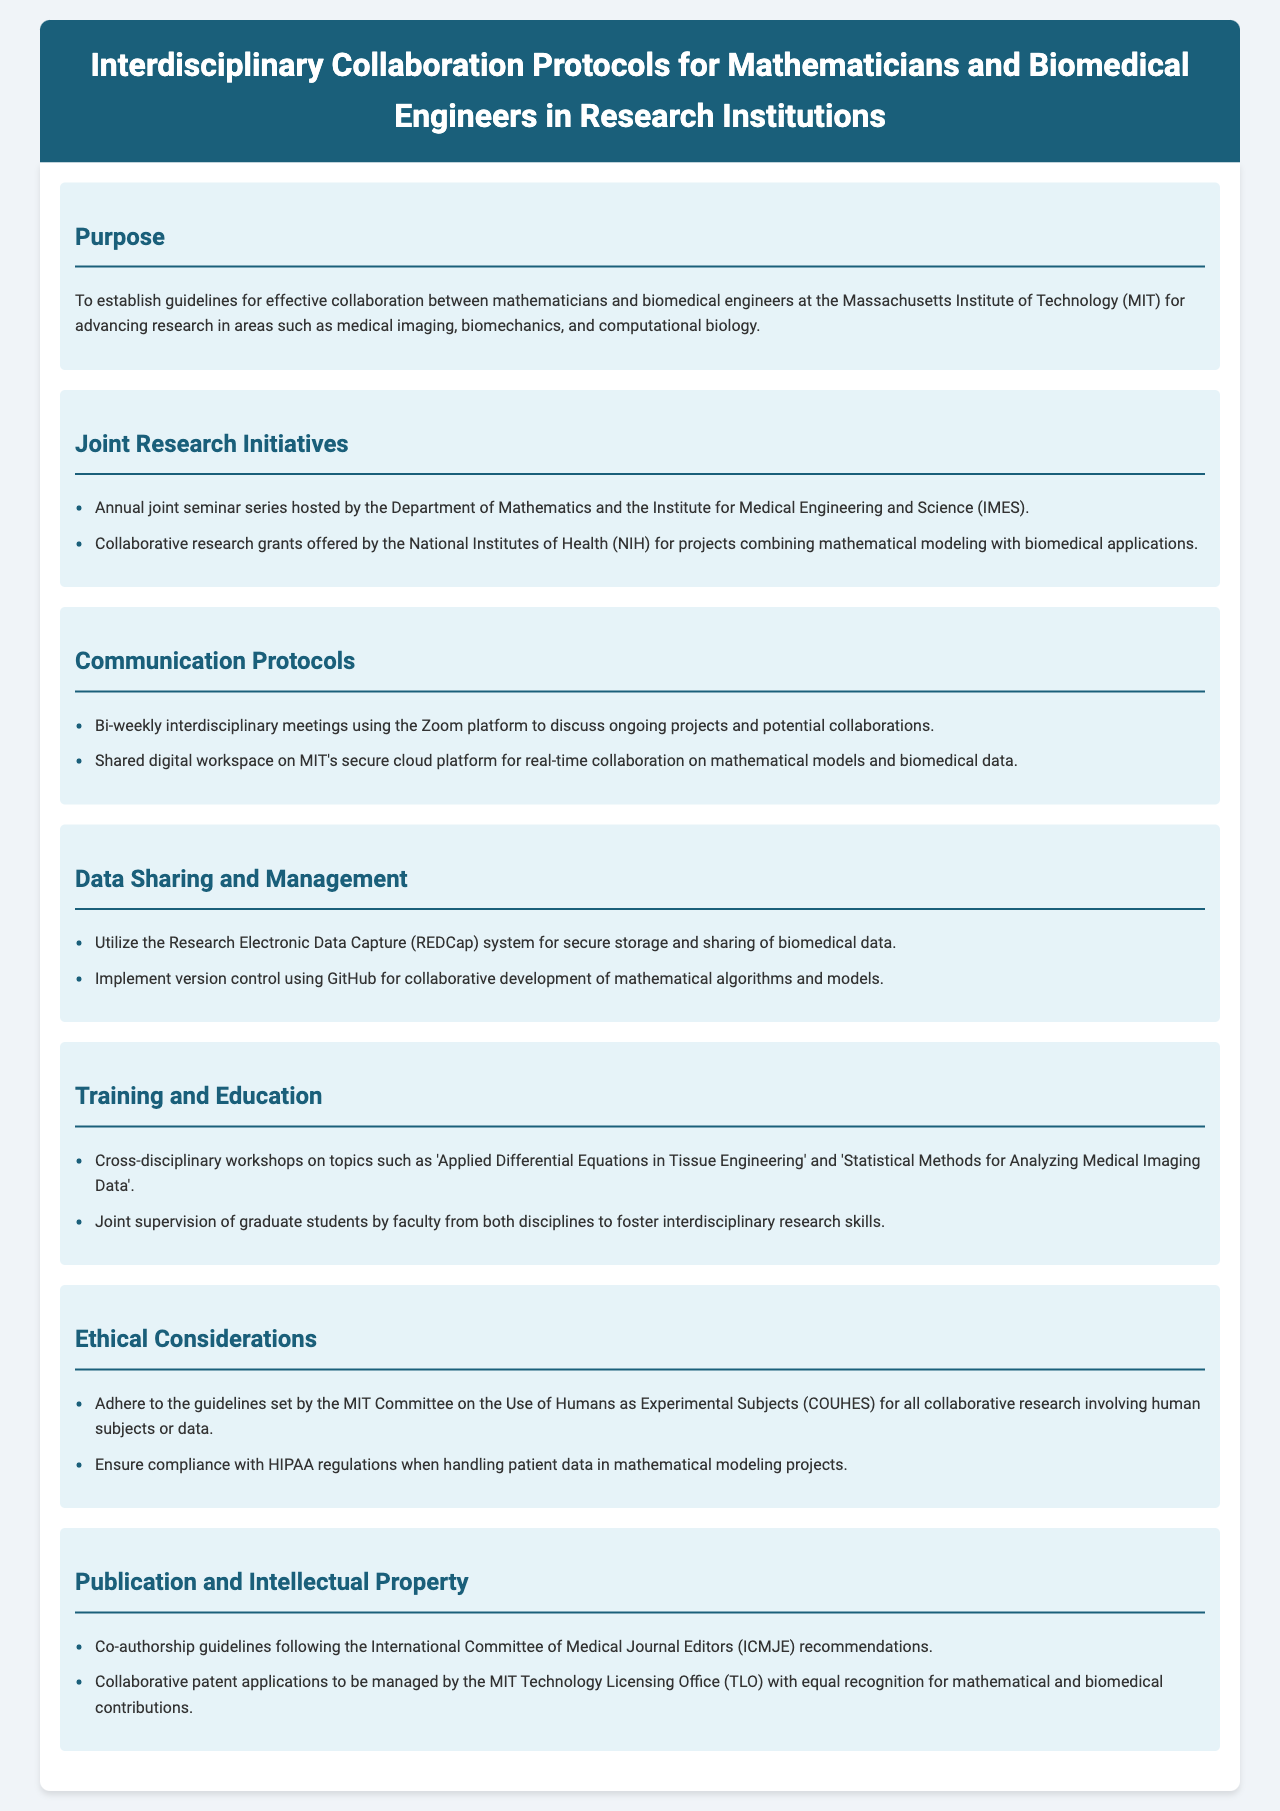what is the purpose of the document? The purpose is to establish guidelines for effective collaboration between mathematicians and biomedical engineers at MIT for advancing research.
Answer: To establish guidelines for effective collaboration how often are interdisciplinary meetings held? The document states that there are bi-weekly meetings to discuss ongoing projects and collaborations.
Answer: Bi-weekly what collaborative initiative is mentioned for cross-disciplinary training? The document lists cross-disciplinary workshops as a training initiative in various topics related to mathematics and biomedical engineering.
Answer: Cross-disciplinary workshops which system is used for secure storage of biomedical data? The document specifies the Research Electronic Data Capture (REDCap) system for secure storage and sharing of biomedical data.
Answer: REDCap what guidelines must be adhered to for research involving human subjects? The document requires adherence to MIT's Committee on the Use of Humans as Experimental Subjects (COUHES) guidelines.
Answer: COUHES how are joint supervision of graduate students structured? The document describes joint supervision by faculty from both mathematics and biomedical engineering to promote interdisciplinary research skills.
Answer: Faculty from both disciplines what are the publication guidelines based on? The document states that co-authorship guidelines follow the International Committee of Medical Journal Editors (ICMJE) recommendations.
Answer: ICMJE what is one of the ethical considerations outlined? The document mentions ensuring compliance with HIPAA regulations when handling patient data in projects.
Answer: HIPAA regulations 